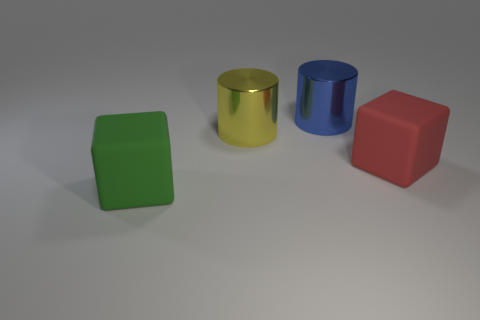There is a thing that is both in front of the yellow metal thing and to the left of the big red object; what material is it?
Ensure brevity in your answer.  Rubber. Is there a purple metallic cylinder?
Your answer should be very brief. No. What is the shape of the matte thing that is on the right side of the big block to the left of the big matte object that is on the right side of the large blue shiny cylinder?
Keep it short and to the point. Cube. What is the shape of the big yellow metal thing?
Your answer should be very brief. Cylinder. There is a matte object on the left side of the yellow cylinder; what is its color?
Provide a succinct answer. Green. There is another object that is the same shape as the blue metal object; what size is it?
Keep it short and to the point. Large. Does the red object have the same shape as the green rubber object?
Offer a very short reply. Yes. Are there fewer blocks that are behind the blue metallic thing than green things on the left side of the large yellow shiny cylinder?
Offer a terse response. Yes. What number of big cylinders are behind the large green rubber object?
Your answer should be compact. 2. Do the big matte thing behind the green matte cube and the large matte object in front of the big red rubber object have the same shape?
Your response must be concise. Yes. 